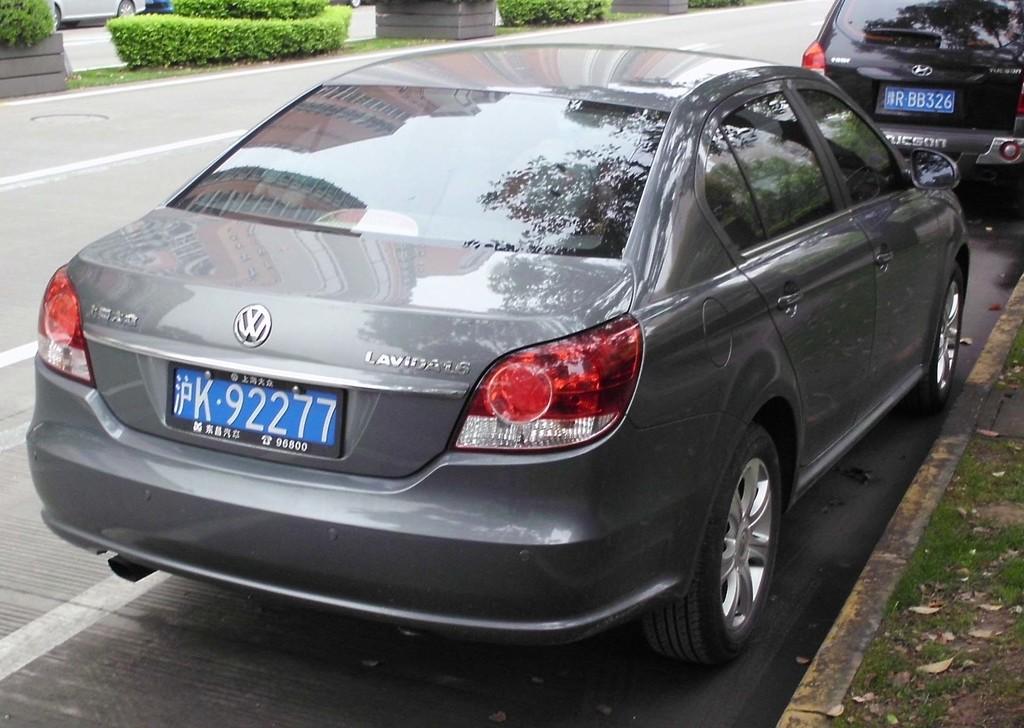What is the plate number of the gray vw?
Your response must be concise. K 92277. What is the car's model name?
Your answer should be compact. Volkswagen. 